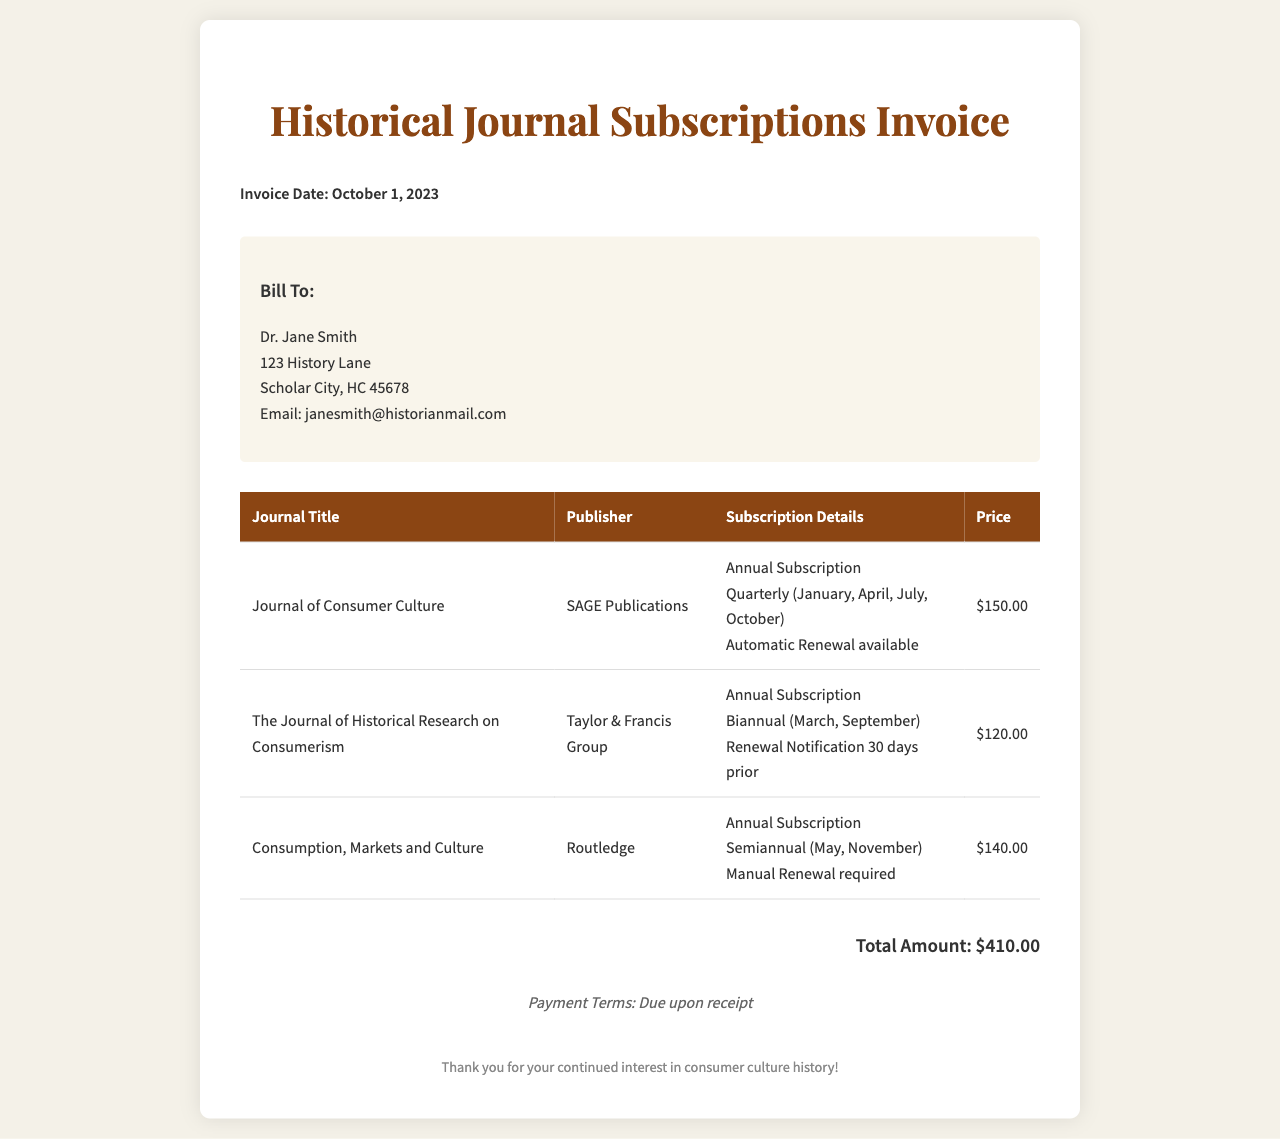What is the invoice date? The invoice date is explicitly mentioned in the document header.
Answer: October 1, 2023 How many journals are listed in the invoice? The invoice includes a table that lists all the journals, which can be counted.
Answer: 3 What is the price of "The Journal of Historical Research on Consumerism"? The price is specified next to the journal title in the table.
Answer: $120.00 Which publisher produces "Consumption, Markets and Culture"? The publisher's name is included in the table beside the journal title.
Answer: Routledge How often is "Journal of Consumer Culture" published? The frequency information is included in the subscription details for the journal.
Answer: Quarterly What are the payment terms? Payment terms are listed at the bottom of the invoice.
Answer: Due upon receipt Which journal requires manual renewal? The renewal method is specified in the subscription details section for the journal.
Answer: Consumption, Markets and Culture When is the renewal notification for "The Journal of Historical Research on Consumerism" sent? The notification timing is stated in the subscription details of the journal.
Answer: 30 days prior What is the total amount due? The total amount is clearly indicated at the end of the invoice.
Answer: $410.00 